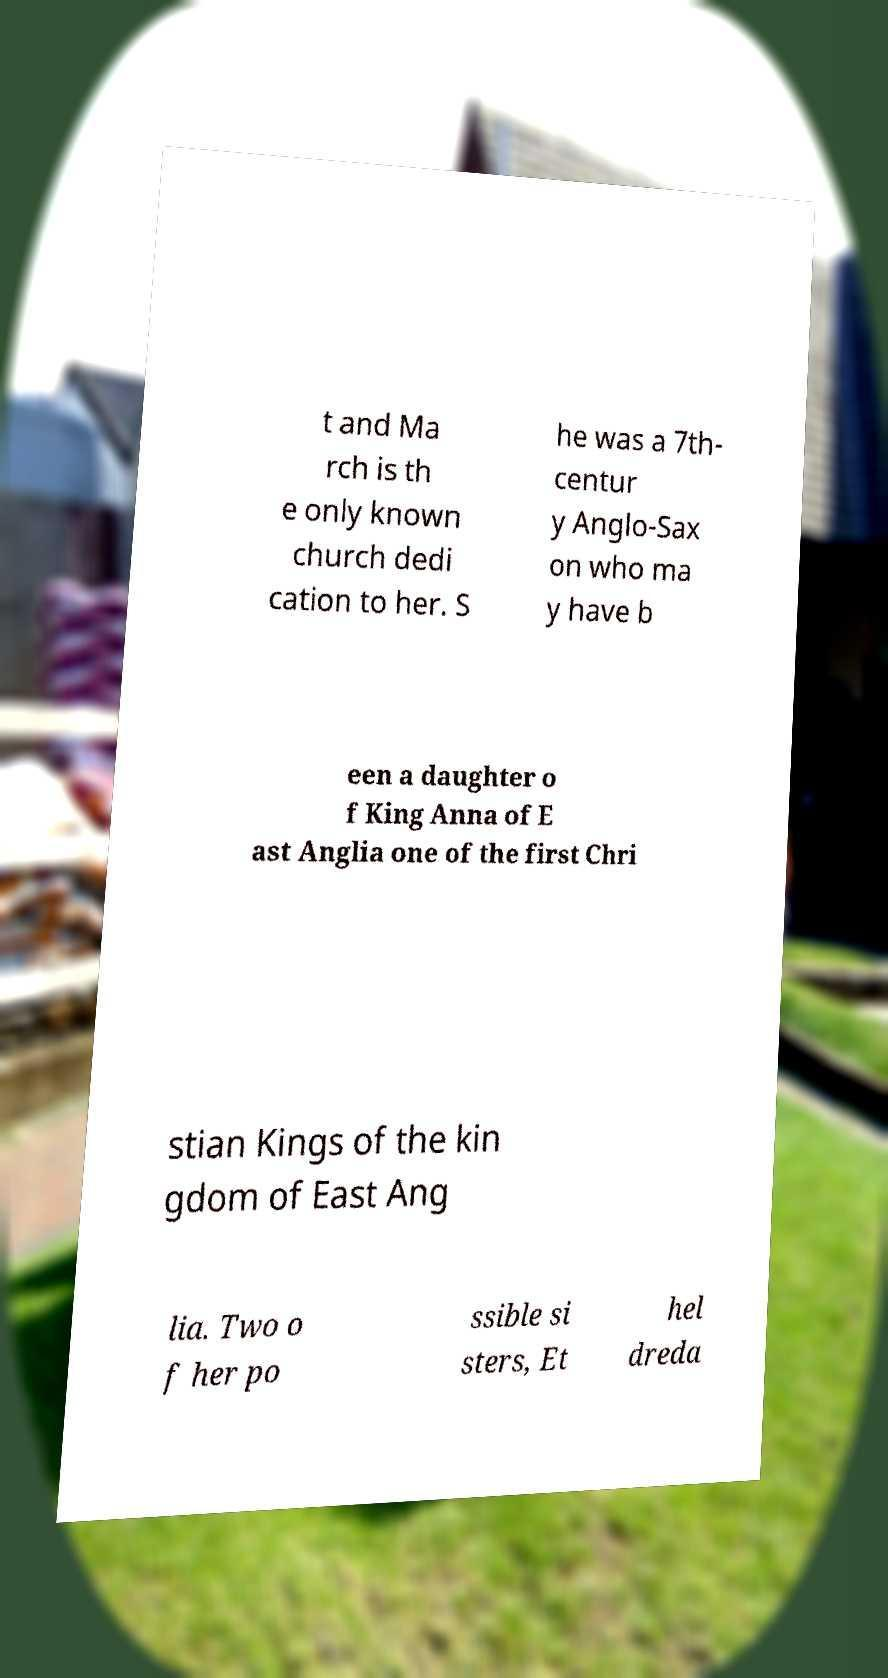There's text embedded in this image that I need extracted. Can you transcribe it verbatim? t and Ma rch is th e only known church dedi cation to her. S he was a 7th- centur y Anglo-Sax on who ma y have b een a daughter o f King Anna of E ast Anglia one of the first Chri stian Kings of the kin gdom of East Ang lia. Two o f her po ssible si sters, Et hel dreda 